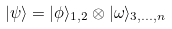<formula> <loc_0><loc_0><loc_500><loc_500>| \psi \rangle = | \phi \rangle _ { 1 , 2 } \otimes | \omega \rangle _ { 3 , \dots , n }</formula> 